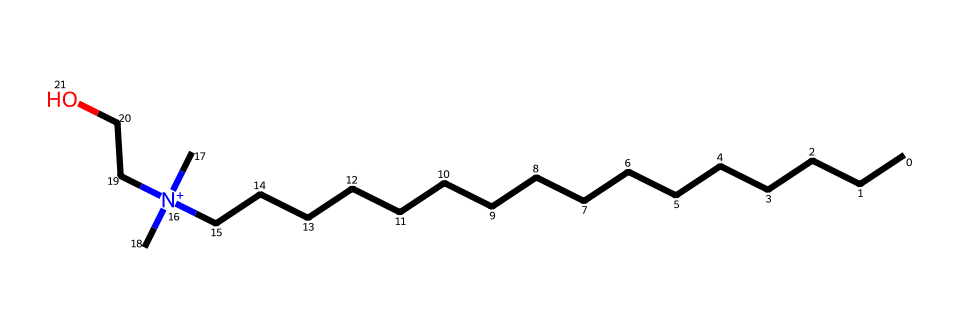What is the total number of carbon atoms in this structure? In the provided SMILES representation, we can identify the carbon atoms based on the "C" symbols. Counting them gives a total of 18 carbon atoms.
Answer: 18 How many nitrogen atoms are present in the structure? The SMILES contains one nitrogen atom, which is represented by the "N" symbol.
Answer: 1 What type of chemical is represented by this structure? The presence of a positively charged nitrogen atom and long hydrocarbon chain indicates that this molecule is a cationic fabric softener, commonly used as a detergent.
Answer: cationic fabric softener What is the molecular feature that gives this chemical its positive charge? The positive charge in the chemical is associated with the nitrogen atom represented by "[N+]". This indicates it accepts an additional bonding electron, resulting in a cation.
Answer: nitrogen Why is the long hydrocarbon chain important for the function of this chemical? The long hydrocarbon chain in the structure contributes to hydrophobic interactions, allowing the chemical to effectively_attach to cloth fibers and provide softness and reduce static cling.
Answer: hydrophobic interactions What functional group is present in this structure? The structure shows the presence of a hydroxyl group "CCO", which is indicative of a 2-hydroxyethyl group. This functionality is often associated with improving the properties of fabric softeners.
Answer: hydroxyl group How many ethyl groups are present in the molecule? Looking closely at the structure, there are two ethyl groups in the molecule as seen by the "CC" notation in "N+(C)(C)".
Answer: 2 